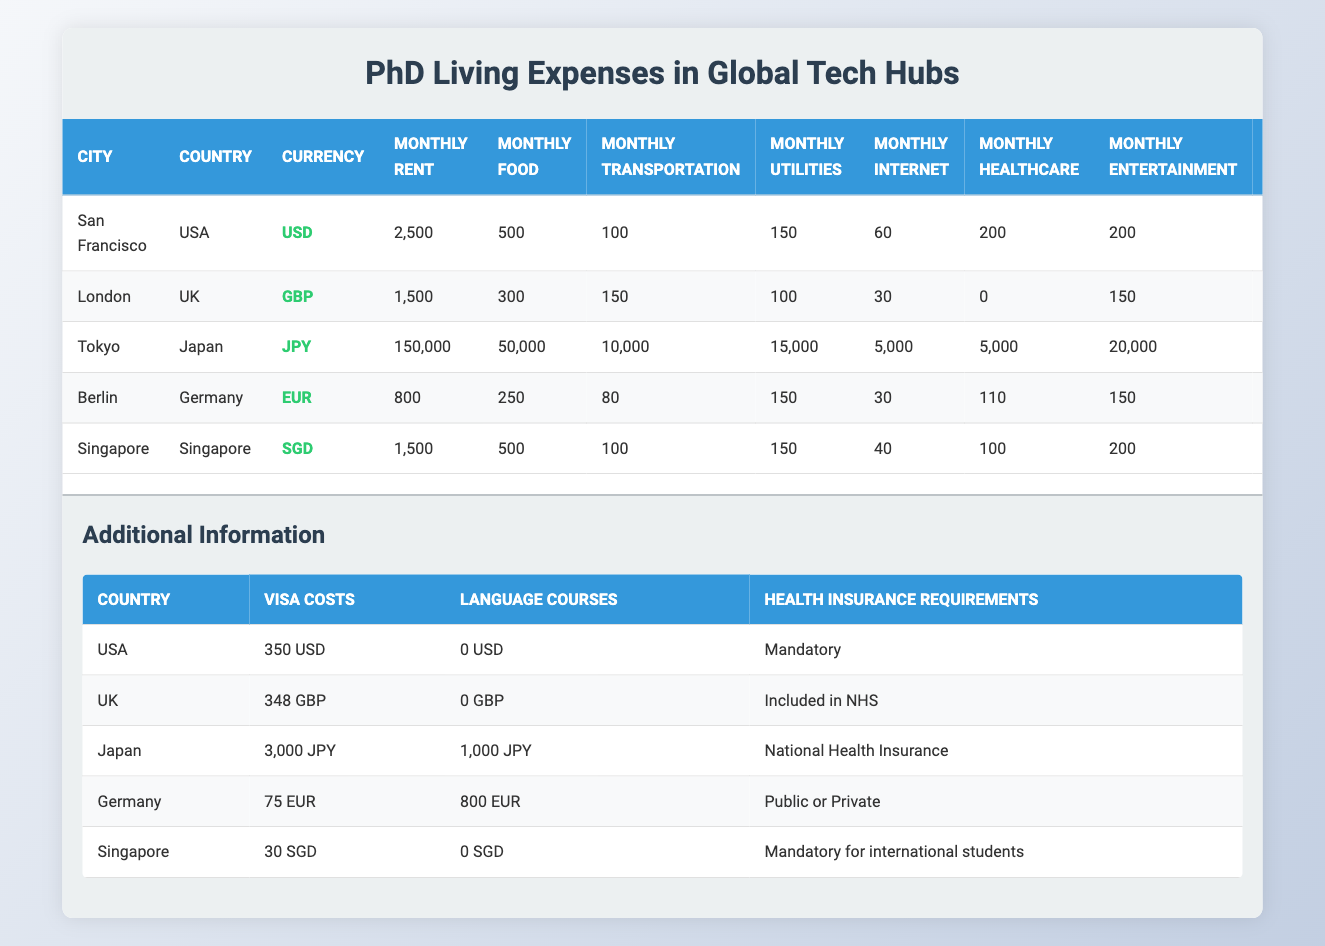What is the total monthly expense for a PhD student in San Francisco? To find the total monthly expense for a PhD student in San Francisco, we need to sum up all the monthly expenses: Rent (2500) + Food (500) + Transportation (100) + Utilities (150) + Internet (60) + Healthcare (200) + Entertainment (200) = 2500 + 500 + 100 + 150 + 60 + 200 + 200 = 3660.
Answer: 3660 What city has the highest annual tuition fee for PhD students? By examining the annual tuition fees listed for each city, we find that Tokyo has the highest annual tuition fee at 535000 JPY.
Answer: Tokyo Is healthcare included in the living expenses for PhD students in London? The living expenses table shows that the monthly healthcare cost in London is listed as 0, which indicates that healthcare is included in the National Health Service (NHS).
Answer: Yes What is the average monthly food expense across all listed cities? To calculate the average monthly food expense, we sum the monthly food expenses for all cities: San Francisco (500) + London (300) + Tokyo (50000) + Berlin (250) + Singapore (500) = 500 + 300 + 50000 + 250 + 500 = 51150. There are 5 cities, so the average is 51150 / 5 = 10230.
Answer: 10230 Which city requires the highest visa costs for international students? Checking the additional information on visa costs, we see that Japan requires the highest visa cost at 3000 JPY.
Answer: Japan What is the difference in monthly rent between San Francisco and Berlin? To find the difference in monthly rent, we subtract the rent in Berlin from the rent in San Francisco: Rent in San Francisco (2500) - Rent in Berlin (800) = 2500 - 800 = 1700.
Answer: 1700 Does all the cities require a health insurance for PhD students? By looking at the health insurance requirements for each country, we see that all cities listed require some form of health insurance: USA (Mandatory), UK (Included in NHS), Japan (National Health Insurance), Germany (Public or Private), Singapore (Mandatory for international students).
Answer: Yes What is the most affordable city in terms of monthly expenses for PhD students? To find the most affordable city, we compare total monthly expenses for each city: San Francisco (3660) > London (2560) > Tokyo (50000) > Berlin (1350) > Singapore (2440). The lowest total monthly expense is in Berlin, which is 1350.
Answer: Berlin How much more is the annual tuition in Tokyo compared to the annual tuition in Berlin? The difference in annual tuition can be calculated by subtracting Berlin's tuition from Tokyo's tuition: Tokyo's tuition (535000) - Berlin's tuition (0) = 535000.
Answer: 535000 